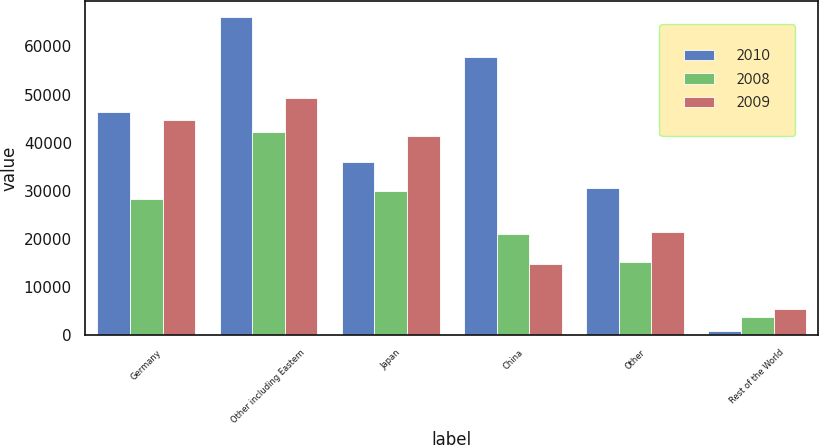Convert chart. <chart><loc_0><loc_0><loc_500><loc_500><stacked_bar_chart><ecel><fcel>Germany<fcel>Other including Eastern<fcel>Japan<fcel>China<fcel>Other<fcel>Rest of the World<nl><fcel>2010<fcel>46282<fcel>66174<fcel>35878<fcel>57762<fcel>30614<fcel>840<nl><fcel>2008<fcel>28242<fcel>42171<fcel>29937<fcel>20942<fcel>15221<fcel>3713<nl><fcel>2009<fcel>44771<fcel>49306<fcel>41310<fcel>14781<fcel>21491<fcel>5399<nl></chart> 